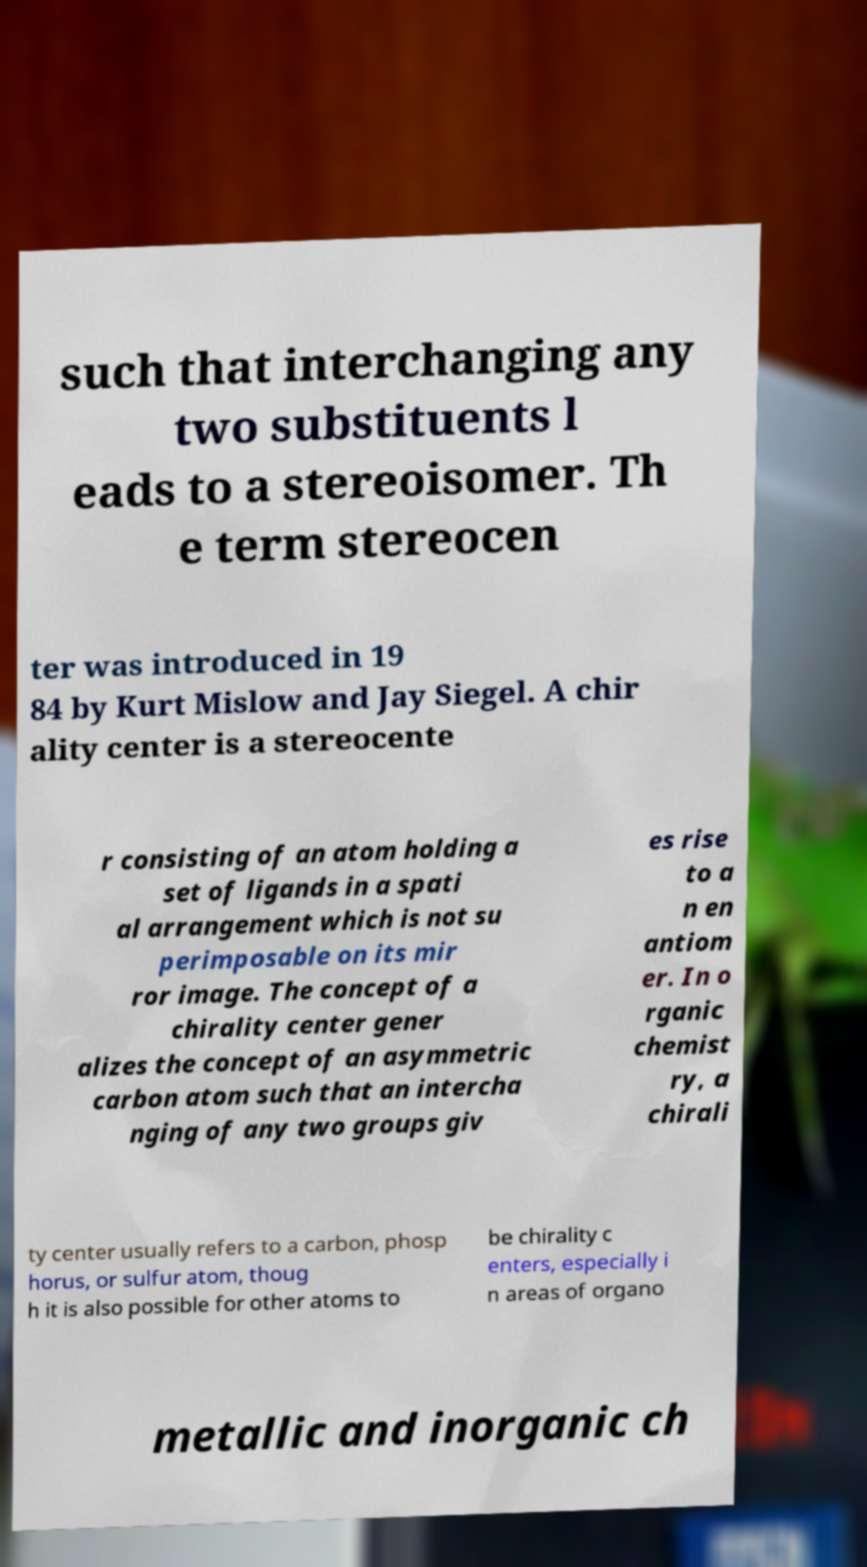Could you extract and type out the text from this image? such that interchanging any two substituents l eads to a stereoisomer. Th e term stereocen ter was introduced in 19 84 by Kurt Mislow and Jay Siegel. A chir ality center is a stereocente r consisting of an atom holding a set of ligands in a spati al arrangement which is not su perimposable on its mir ror image. The concept of a chirality center gener alizes the concept of an asymmetric carbon atom such that an intercha nging of any two groups giv es rise to a n en antiom er. In o rganic chemist ry, a chirali ty center usually refers to a carbon, phosp horus, or sulfur atom, thoug h it is also possible for other atoms to be chirality c enters, especially i n areas of organo metallic and inorganic ch 